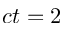Convert formula to latex. <formula><loc_0><loc_0><loc_500><loc_500>c t = 2</formula> 